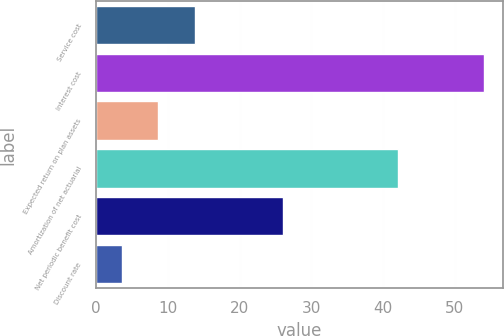Convert chart. <chart><loc_0><loc_0><loc_500><loc_500><bar_chart><fcel>Service cost<fcel>Interest cost<fcel>Expected return on plan assets<fcel>Amortization of net actuarial<fcel>Net periodic benefit cost<fcel>Discount rate<nl><fcel>13.72<fcel>54<fcel>8.69<fcel>42<fcel>26<fcel>3.65<nl></chart> 